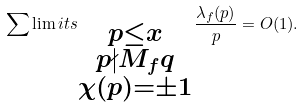Convert formula to latex. <formula><loc_0><loc_0><loc_500><loc_500>\sum \lim i t s _ { \substack { p \leq x \\ p \nmid M _ { f } q \\ \chi ( p ) = \pm 1 } } \frac { \lambda _ { f } ( p ) } { p } = O ( 1 ) .</formula> 